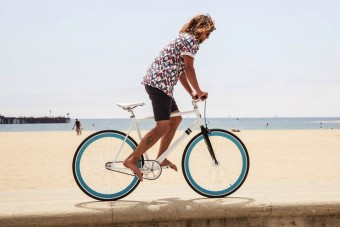How many boats would there be in the image after one more boat has been added in the image? Based on the current image where no boats are visible, adding one boat would result in a total of one boat in the scene. 